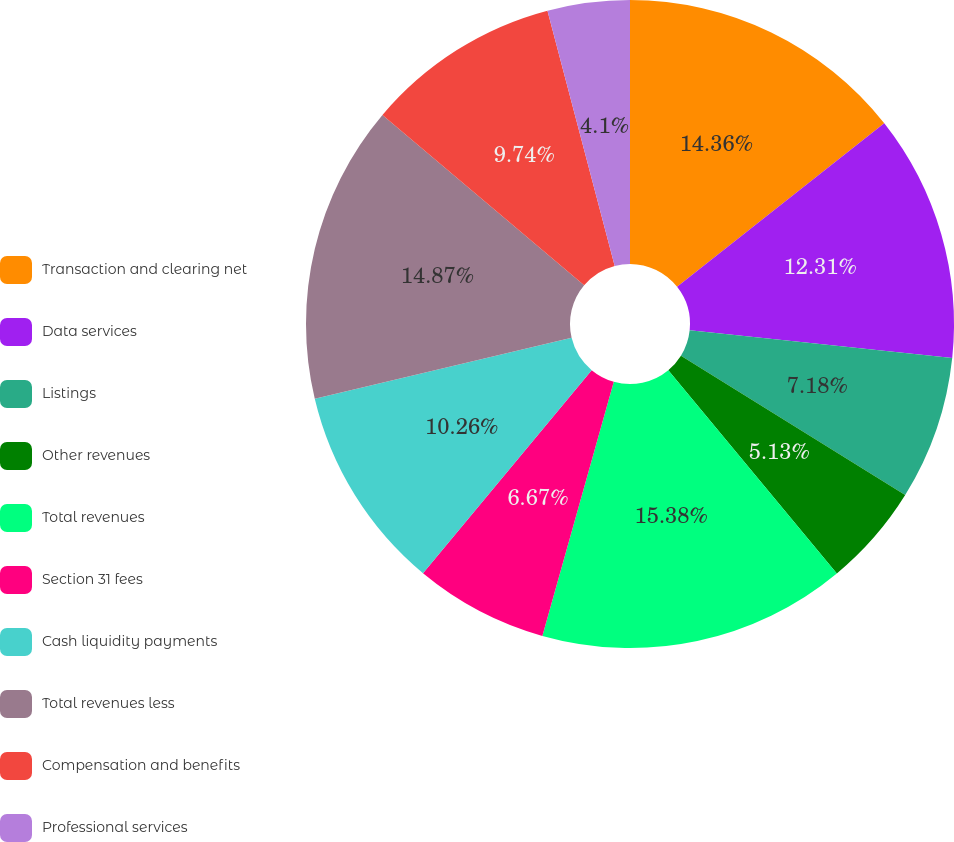Convert chart. <chart><loc_0><loc_0><loc_500><loc_500><pie_chart><fcel>Transaction and clearing net<fcel>Data services<fcel>Listings<fcel>Other revenues<fcel>Total revenues<fcel>Section 31 fees<fcel>Cash liquidity payments<fcel>Total revenues less<fcel>Compensation and benefits<fcel>Professional services<nl><fcel>14.36%<fcel>12.31%<fcel>7.18%<fcel>5.13%<fcel>15.38%<fcel>6.67%<fcel>10.26%<fcel>14.87%<fcel>9.74%<fcel>4.1%<nl></chart> 